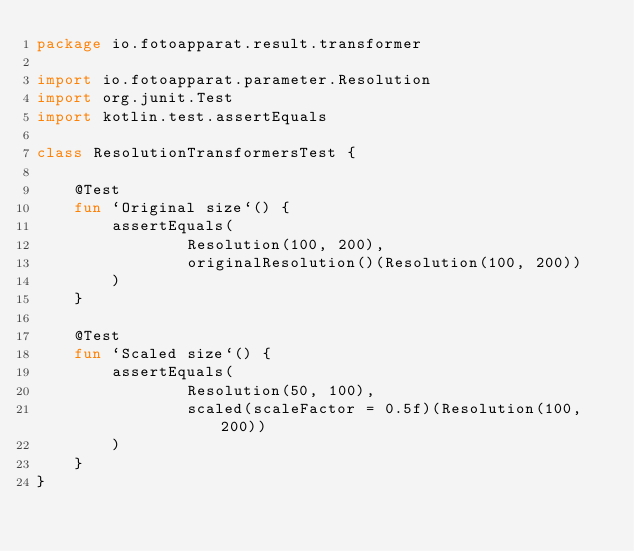Convert code to text. <code><loc_0><loc_0><loc_500><loc_500><_Kotlin_>package io.fotoapparat.result.transformer

import io.fotoapparat.parameter.Resolution
import org.junit.Test
import kotlin.test.assertEquals

class ResolutionTransformersTest {

    @Test
    fun `Original size`() {
        assertEquals(
                Resolution(100, 200),
                originalResolution()(Resolution(100, 200))
        )
    }

    @Test
    fun `Scaled size`() {
        assertEquals(
                Resolution(50, 100),
                scaled(scaleFactor = 0.5f)(Resolution(100, 200))
        )
    }
}</code> 